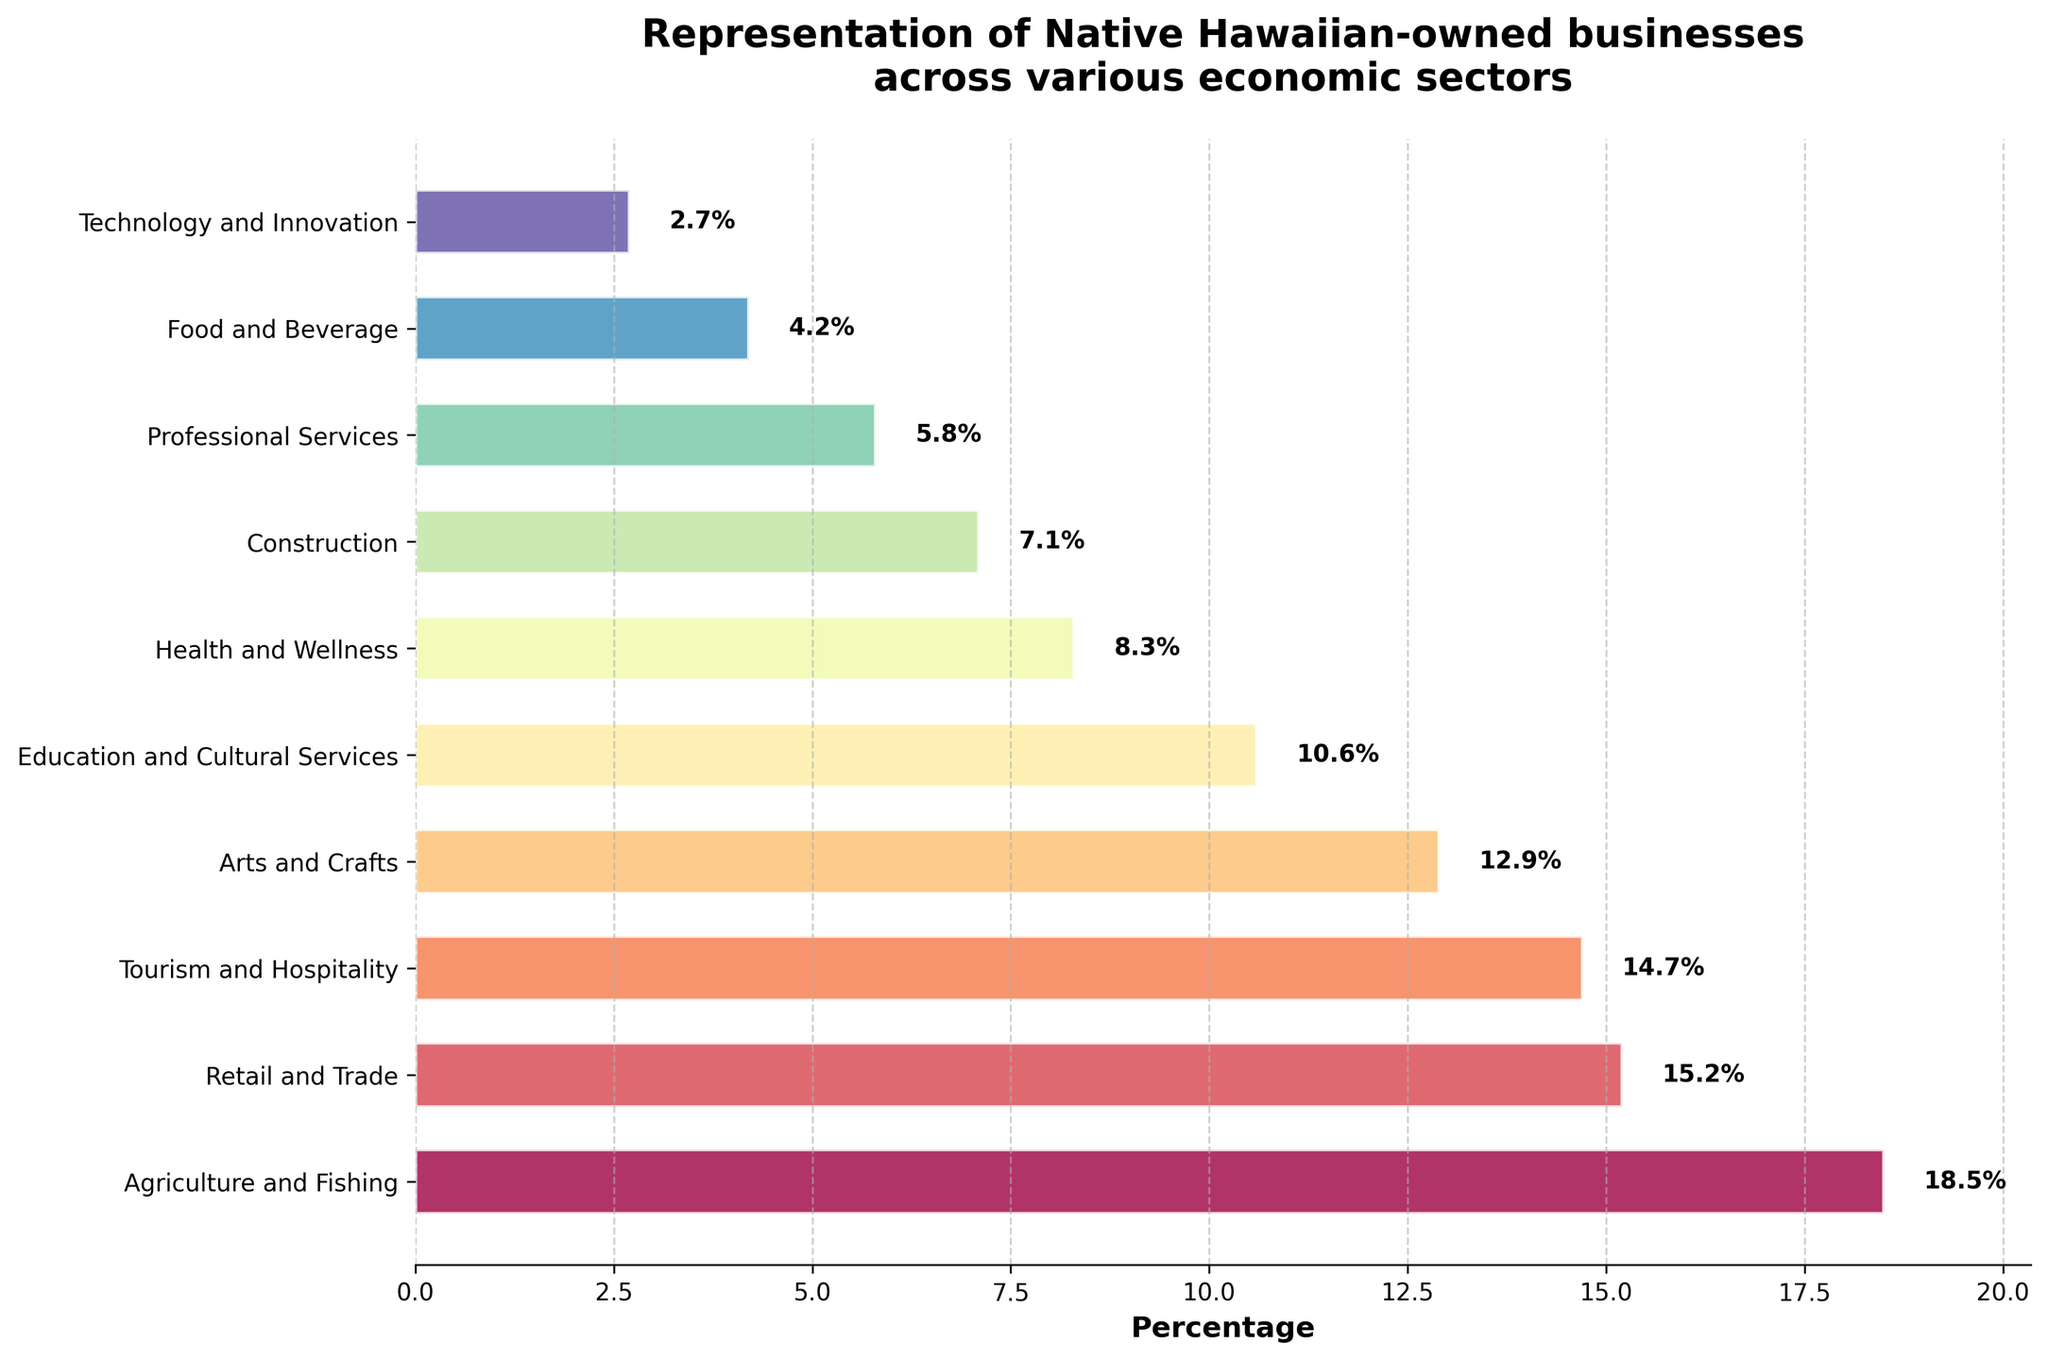Which sector has the highest percentage of Native Hawaiian-owned businesses? By observing the length of the bars in the chart, the Agriculture and Fishing sector has the highest percentage, as indicated by the longest bar.
Answer: Agriculture and Fishing Which sector has the lowest percentage of Native Hawaiian-owned businesses? By observing the length of the bars in the chart, the Technology and Innovation sector has the lowest percentage, as indicated by the shortest bar.
Answer: Technology and Innovation What is the difference in percentage between the Agriculture and Fishing sector and the Technology and Innovation sector? The percentage for Agriculture and Fishing is 18.5%, and for Technology and Innovation, it is 2.7%. The difference is calculated as 18.5% - 2.7% = 15.8%.
Answer: 15.8% Which sector has a higher percentage, Arts and Crafts or Health and Wellness? The percentage for Arts and Crafts is 12.9%, and for Health and Wellness, it is 8.3%. Since 12.9% is greater than 8.3%, the Arts and Crafts sector has a higher percentage.
Answer: Arts and Crafts What is the combined percentage of the sectors Tourism and Hospitality, Retail and Trade, and Food and Beverage? The percentages for Tourism and Hospitality, Retail and Trade, and Food and Beverage are 14.7%, 15.2%, and 4.2%, respectively. The combined percentage is 14.7% + 15.2% + 4.2% = 34.1%.
Answer: 34.1% What is the approximate average percentage of the sectors with percentages below 10%? The sectors with percentages below 10% are Education and Cultural Services (10.6%), Health and Wellness (8.3%), Construction (7.1%), Professional Services (5.8%), Food and Beverage (4.2%), and Technology and Innovation (2.7%). The average is calculated as (10.6 + 8.3 + 7.1 + 5.8 + 4.2 + 2.7) / 6 ≈ 6.45%.
Answer: 6.45% How many sectors have a percentage higher than 10%? By observing the chart, the sectors with percentages higher than 10% are Agriculture and Fishing (18.5%), Retail and Trade (15.2%), Tourism and Hospitality (14.7%), Arts and Crafts (12.9%), and Education and Cultural Services (10.6%). There are 5 such sectors.
Answer: 5 Does the Retail and Trade sector have a higher percentage than the Tourism and Hospitality sector? The percentage for Retail and Trade is 15.2%, and for Tourism and Hospitality, it is 14.7%. Since 15.2% is greater than 14.7%, the Retail and Trade sector has a higher percentage.
Answer: Yes What is the total percentage accounted for by the top three sectors? The top three sectors are Agriculture and Fishing (18.5%), Retail and Trade (15.2%), and Tourism and Hospitality (14.7%). Their total percentage is 18.5% + 15.2% + 14.7% = 48.4%.
Answer: 48.4% What is the difference in percentage between the highest and the lowest sector within the top five sectors? The highest percentage in the top five sectors is Agriculture and Fishing (18.5%), and the lowest is Education and Cultural Services (10.6%). The difference is calculated as 18.5% - 10.6% = 7.9%.
Answer: 7.9% 